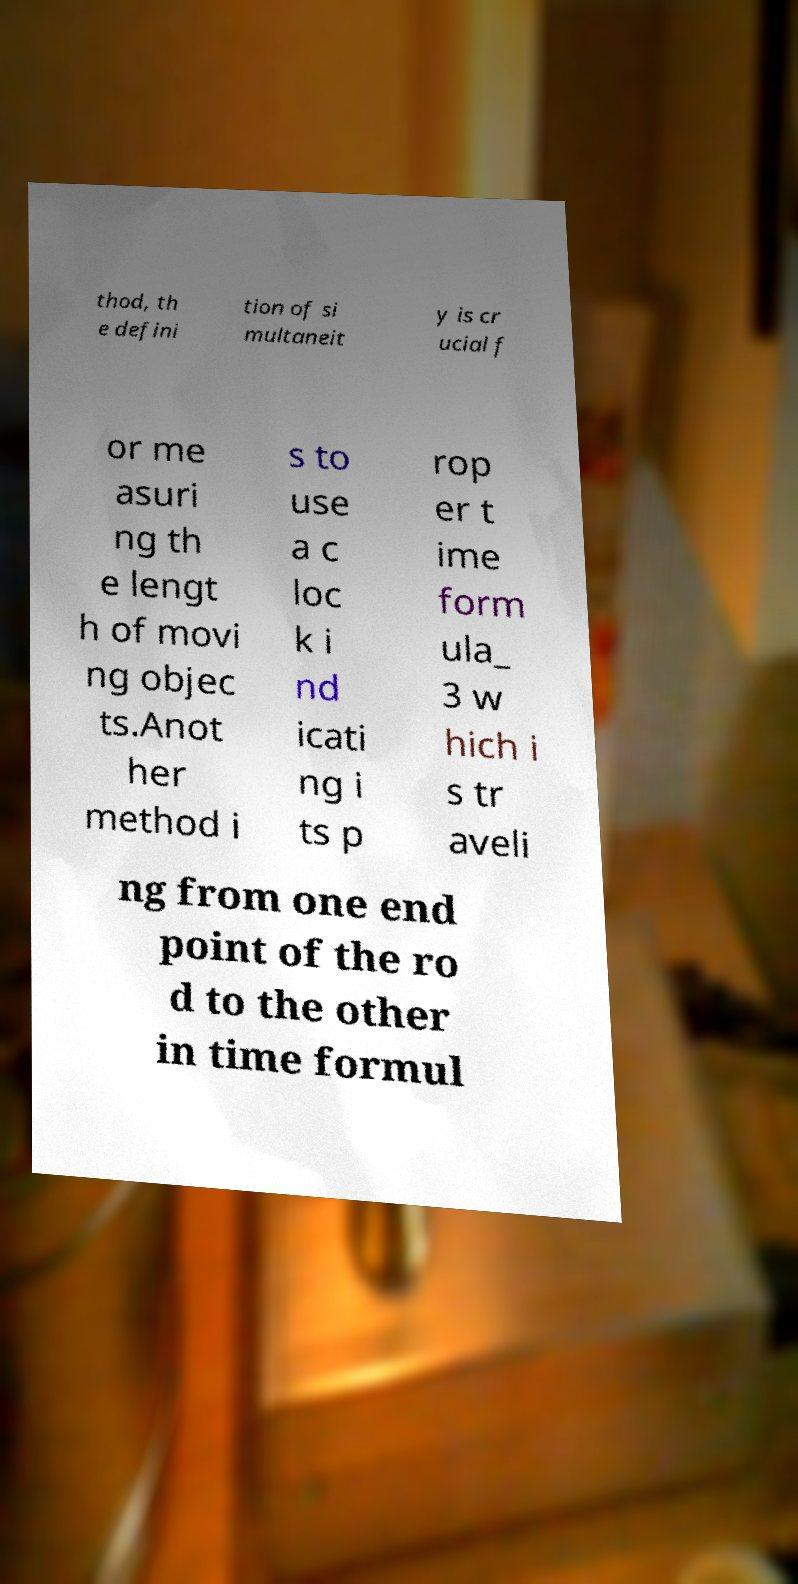Could you assist in decoding the text presented in this image and type it out clearly? thod, th e defini tion of si multaneit y is cr ucial f or me asuri ng th e lengt h of movi ng objec ts.Anot her method i s to use a c loc k i nd icati ng i ts p rop er t ime form ula_ 3 w hich i s tr aveli ng from one end point of the ro d to the other in time formul 